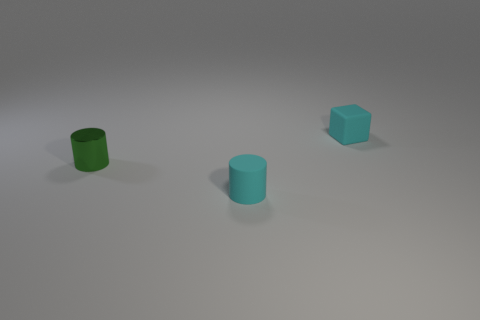What is the color of the other matte cylinder that is the same size as the green cylinder?
Give a very brief answer. Cyan. What shape is the tiny rubber thing that is the same color as the tiny matte block?
Your answer should be compact. Cylinder. There is a object that is left of the small cyan block and behind the cyan cylinder; what is its material?
Provide a short and direct response. Metal. There is a tiny rubber object that is the same shape as the green metallic thing; what color is it?
Make the answer very short. Cyan. Are there any other things of the same color as the shiny object?
Your answer should be compact. No. There is a cyan rubber object that is behind the small metal cylinder; is its size the same as the object that is left of the tiny matte cylinder?
Ensure brevity in your answer.  Yes. Are there the same number of tiny green things that are behind the green shiny thing and matte objects that are left of the small matte cube?
Offer a very short reply. No. Is there a small object that is behind the small cylinder that is to the right of the small metal object?
Give a very brief answer. Yes. Is there a cyan thing of the same shape as the green object?
Your answer should be compact. Yes. There is a cyan rubber object behind the tiny cyan rubber object that is in front of the block; what number of cyan matte objects are on the right side of it?
Make the answer very short. 0. 